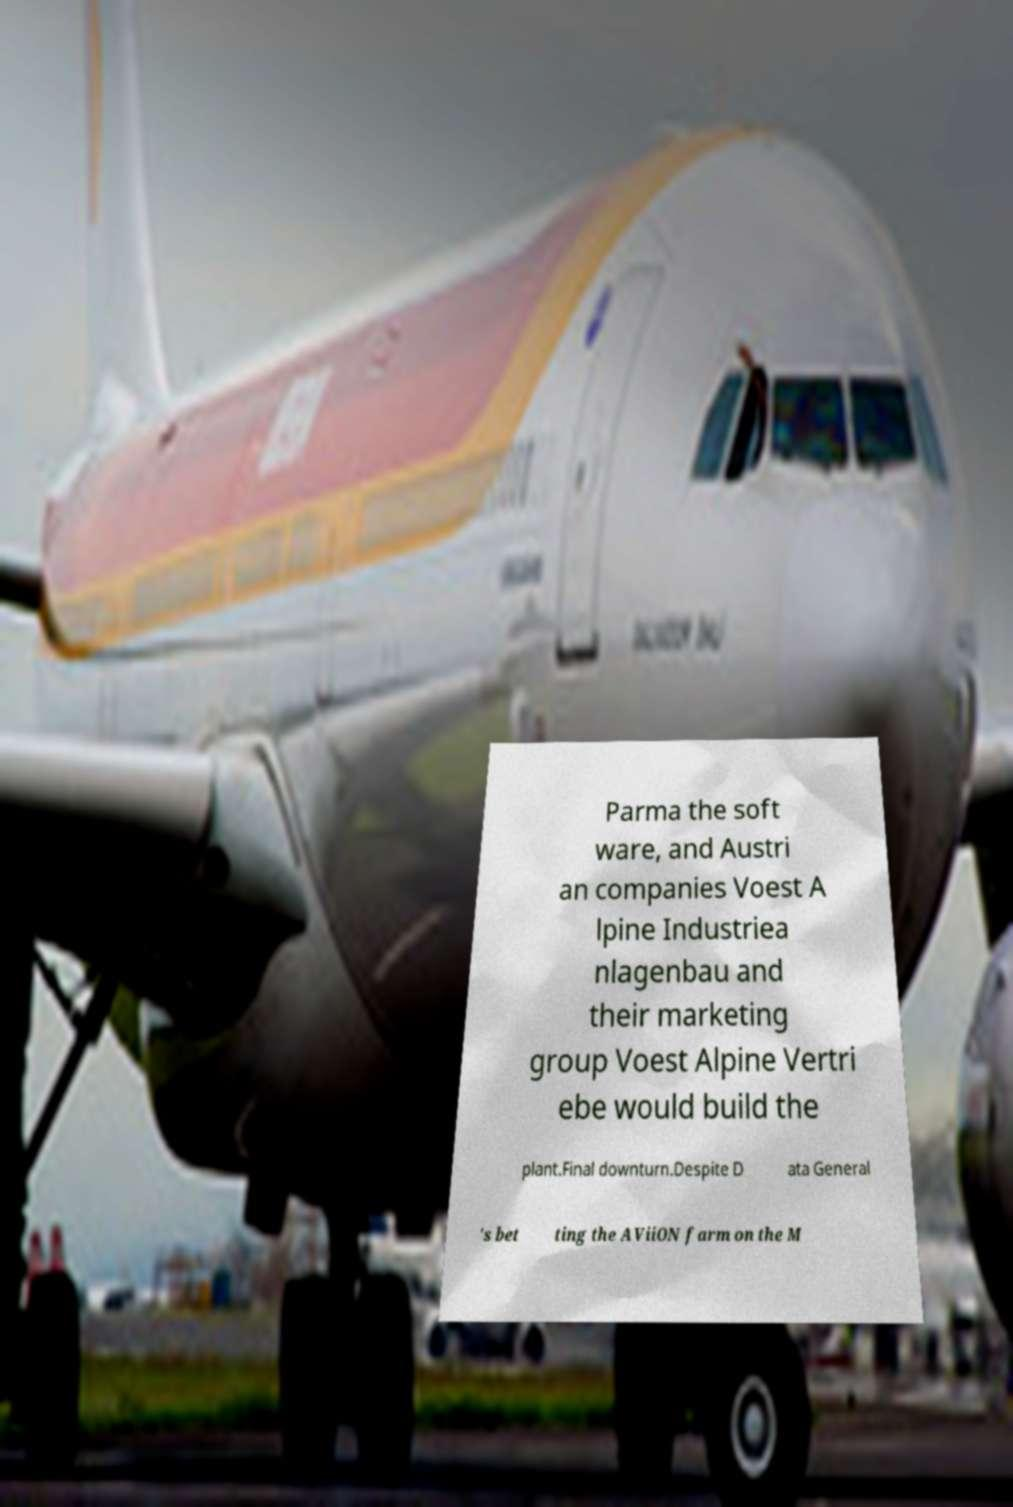What messages or text are displayed in this image? I need them in a readable, typed format. Parma the soft ware, and Austri an companies Voest A lpine Industriea nlagenbau and their marketing group Voest Alpine Vertri ebe would build the plant.Final downturn.Despite D ata General 's bet ting the AViiON farm on the M 